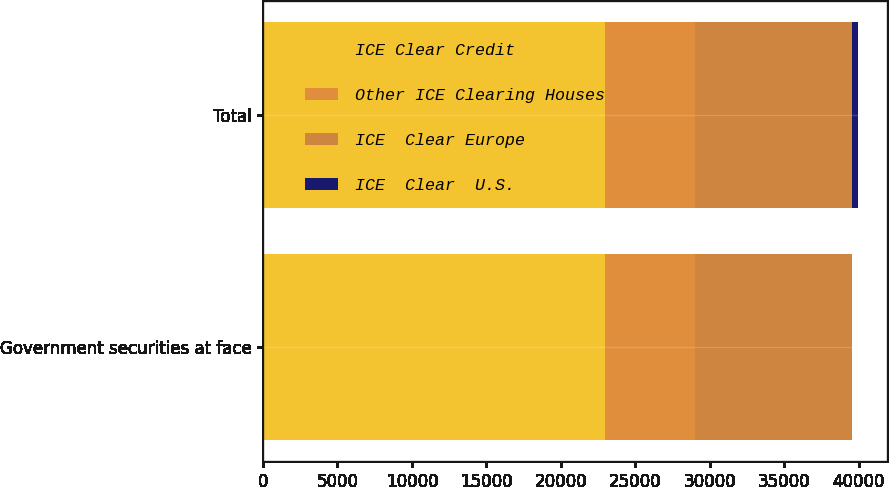Convert chart. <chart><loc_0><loc_0><loc_500><loc_500><stacked_bar_chart><ecel><fcel>Government securities at face<fcel>Total<nl><fcel>ICE Clear Credit<fcel>22961<fcel>22961<nl><fcel>Other ICE Clearing Houses<fcel>6013<fcel>6013<nl><fcel>ICE  Clear Europe<fcel>10542<fcel>10542<nl><fcel>ICE  Clear  U.S.<fcel>37<fcel>405<nl></chart> 